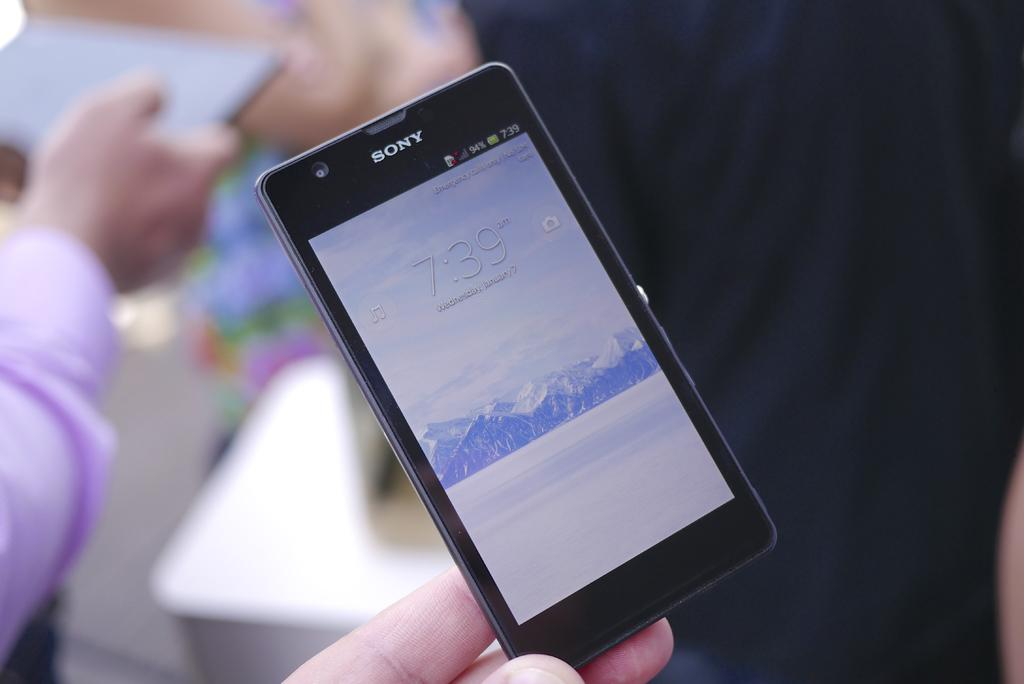<image>
Create a compact narrative representing the image presented. A Sony smartphone on the wake screen being held in someone's fingertips. 